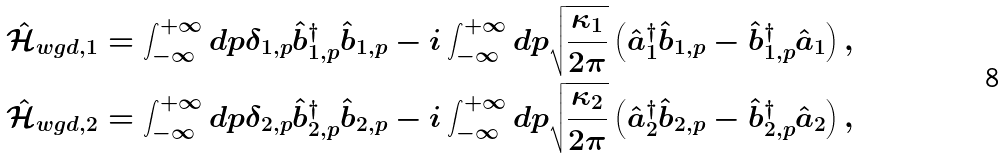<formula> <loc_0><loc_0><loc_500><loc_500>& \hat { \mathcal { H } } _ { w g d , 1 } = \int _ { - \infty } ^ { + \infty } d p \delta _ { 1 , p } \hat { b } _ { 1 , p } ^ { \dagger } \hat { b } _ { 1 , p } - i \int _ { - \infty } ^ { + \infty } d p \sqrt { \frac { \kappa _ { 1 } } { 2 \pi } } \left ( \hat { a } _ { 1 } ^ { \dagger } \hat { b } _ { 1 , p } - \hat { b } _ { 1 , p } ^ { \dagger } \hat { a } _ { 1 } \right ) , \\ & \hat { \mathcal { H } } _ { w g d , 2 } = \int _ { - \infty } ^ { + \infty } d p \delta _ { 2 , p } \hat { b } _ { 2 , p } ^ { \dagger } \hat { b } _ { 2 , p } - i \int _ { - \infty } ^ { + \infty } d p \sqrt { \frac { \kappa _ { 2 } } { 2 \pi } } \left ( \hat { a } _ { 2 } ^ { \dagger } \hat { b } _ { 2 , p } - \hat { b } _ { 2 , p } ^ { \dagger } \hat { a } _ { 2 } \right ) ,</formula> 